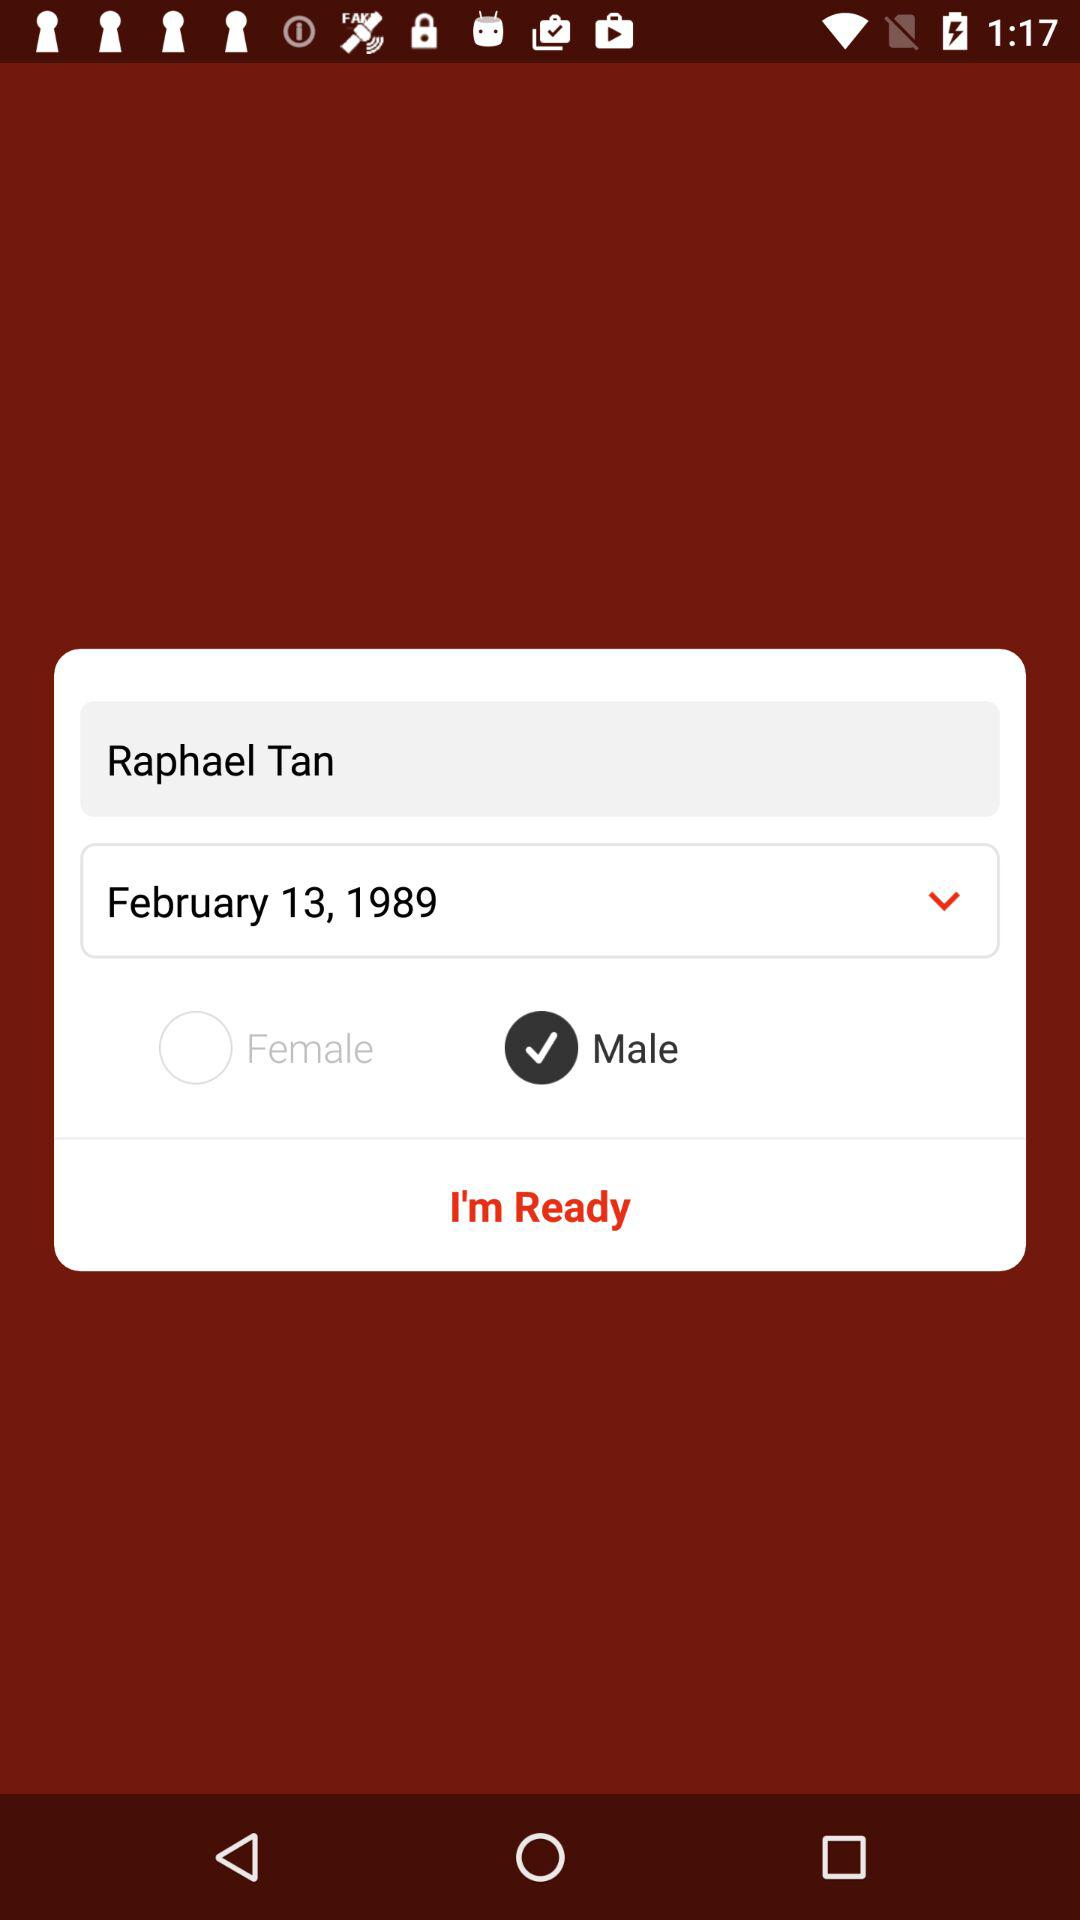How many check boxes are there?
Answer the question using a single word or phrase. 2 